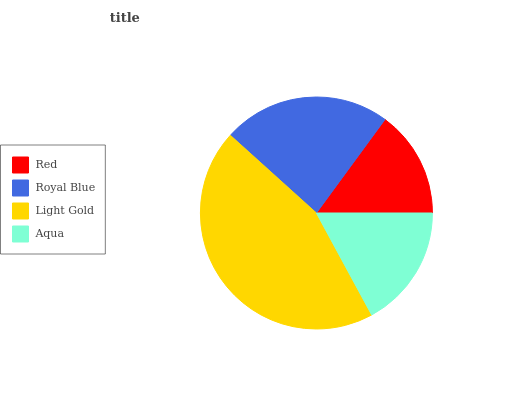Is Red the minimum?
Answer yes or no. Yes. Is Light Gold the maximum?
Answer yes or no. Yes. Is Royal Blue the minimum?
Answer yes or no. No. Is Royal Blue the maximum?
Answer yes or no. No. Is Royal Blue greater than Red?
Answer yes or no. Yes. Is Red less than Royal Blue?
Answer yes or no. Yes. Is Red greater than Royal Blue?
Answer yes or no. No. Is Royal Blue less than Red?
Answer yes or no. No. Is Royal Blue the high median?
Answer yes or no. Yes. Is Aqua the low median?
Answer yes or no. Yes. Is Red the high median?
Answer yes or no. No. Is Light Gold the low median?
Answer yes or no. No. 